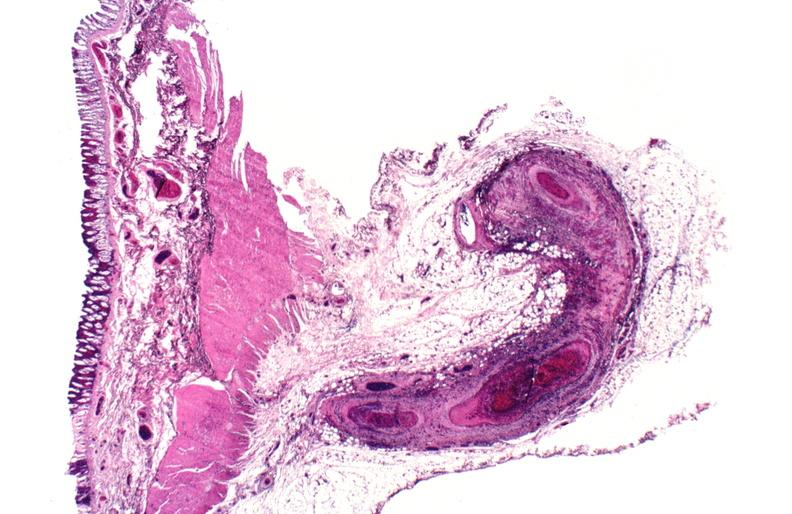s artery present?
Answer the question using a single word or phrase. No 